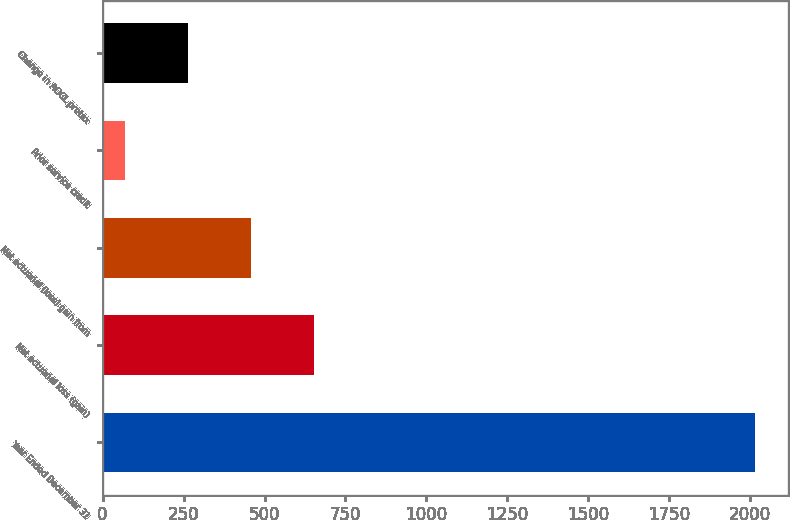Convert chart. <chart><loc_0><loc_0><loc_500><loc_500><bar_chart><fcel>Year Ended December 31<fcel>Net actuarial loss (gain)<fcel>Net actuarial (loss) gain from<fcel>Prior service credit<fcel>Change in AOCL pretax<nl><fcel>2016<fcel>652.4<fcel>457.6<fcel>68<fcel>262.8<nl></chart> 